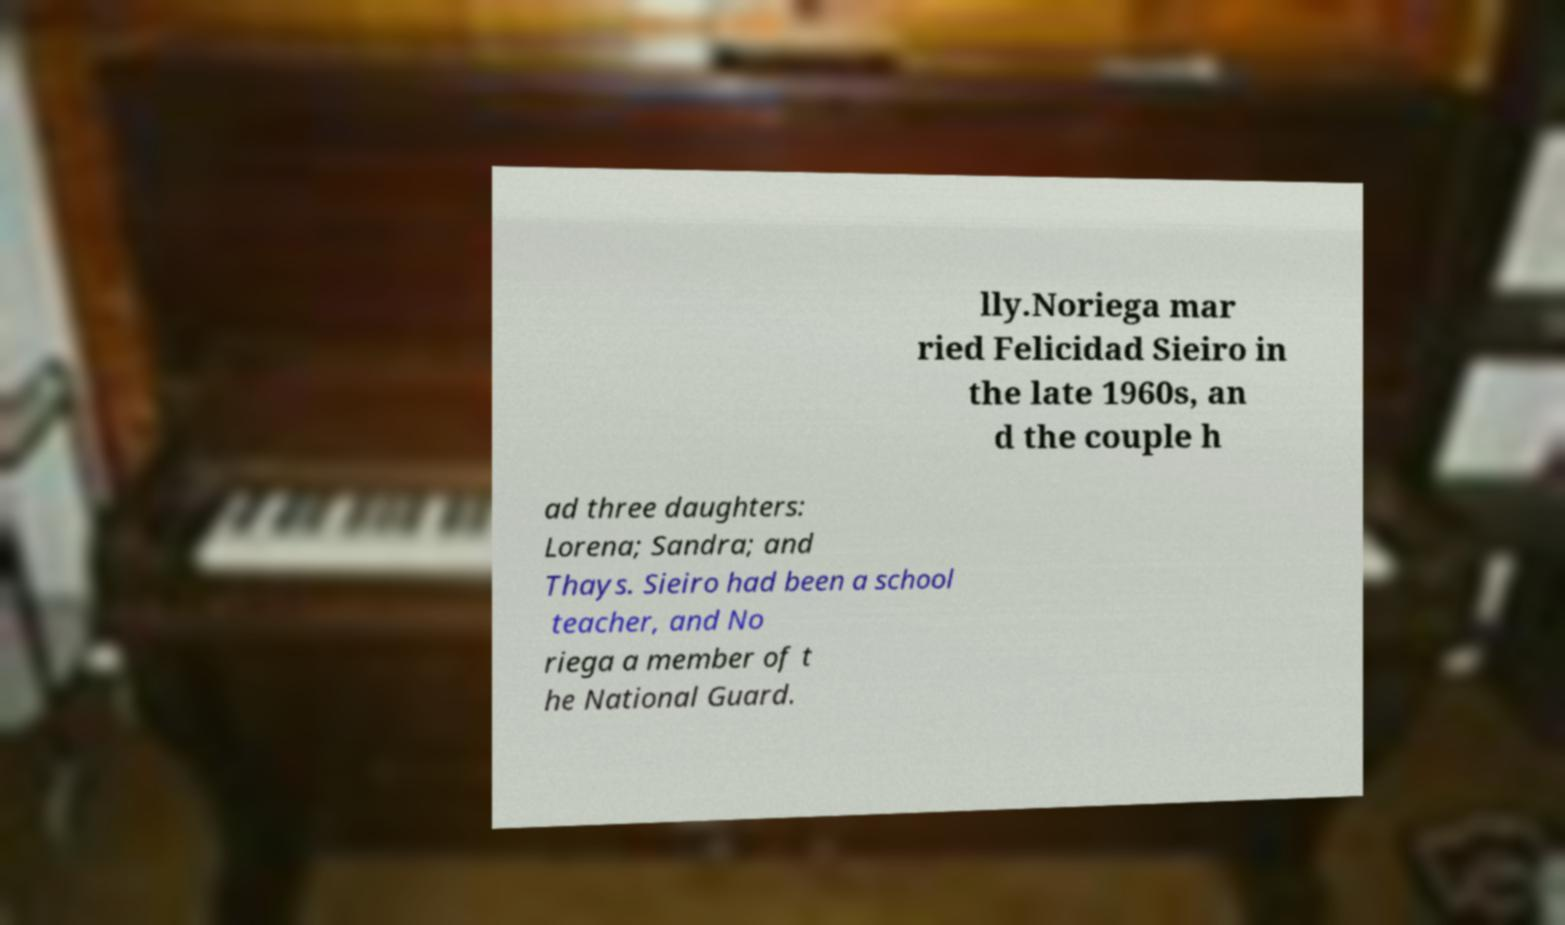Could you assist in decoding the text presented in this image and type it out clearly? lly.Noriega mar ried Felicidad Sieiro in the late 1960s, an d the couple h ad three daughters: Lorena; Sandra; and Thays. Sieiro had been a school teacher, and No riega a member of t he National Guard. 